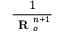<formula> <loc_0><loc_0><loc_500><loc_500>\frac { 1 } { R _ { o } ^ { n + 1 } }</formula> 